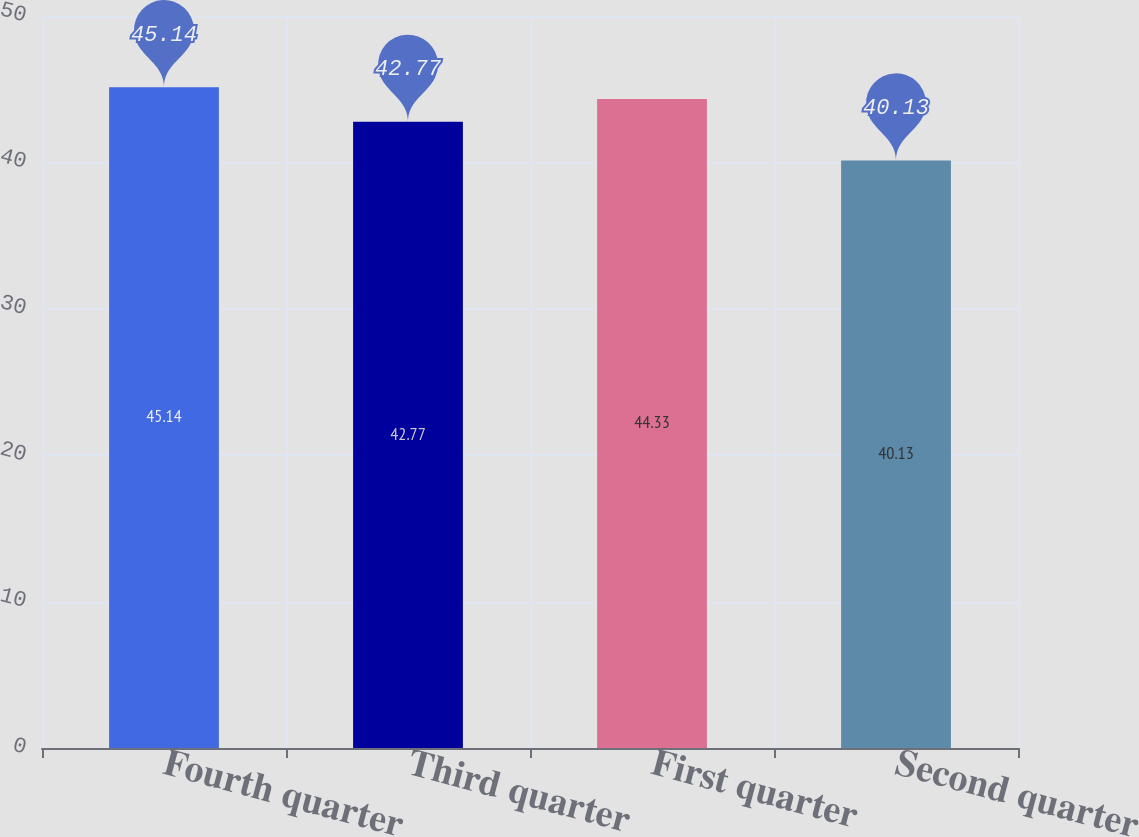Convert chart. <chart><loc_0><loc_0><loc_500><loc_500><bar_chart><fcel>Fourth quarter<fcel>Third quarter<fcel>First quarter<fcel>Second quarter<nl><fcel>45.14<fcel>42.77<fcel>44.33<fcel>40.13<nl></chart> 